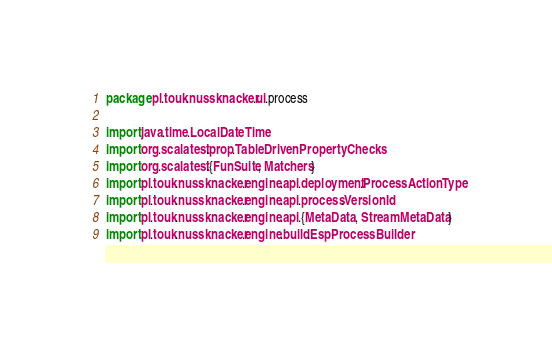Convert code to text. <code><loc_0><loc_0><loc_500><loc_500><_Scala_>package pl.touk.nussknacker.ui.process

import java.time.LocalDateTime
import org.scalatest.prop.TableDrivenPropertyChecks
import org.scalatest.{FunSuite, Matchers}
import pl.touk.nussknacker.engine.api.deployment.ProcessActionType
import pl.touk.nussknacker.engine.api.process.VersionId
import pl.touk.nussknacker.engine.api.{MetaData, StreamMetaData}
import pl.touk.nussknacker.engine.build.EspProcessBuilder</code> 